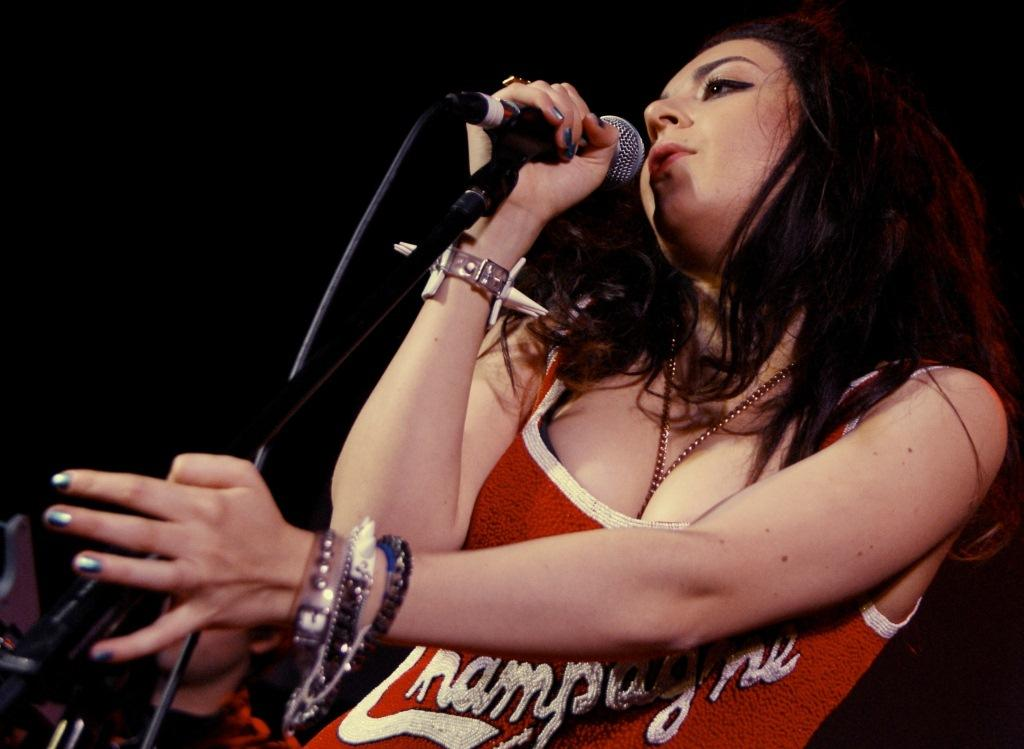Who is the main subject in the image? There is a woman in the image. What is the woman wearing? The woman is wearing a red top. Where is the woman positioned in the image? The woman is standing in the front. What is the woman doing in the image? The woman is singing into a microphone. What is the color of the background in the image? There is a black background in the image. How many goldfish can be seen swimming in the background of the image? There are no goldfish present in the image; the background is black. 